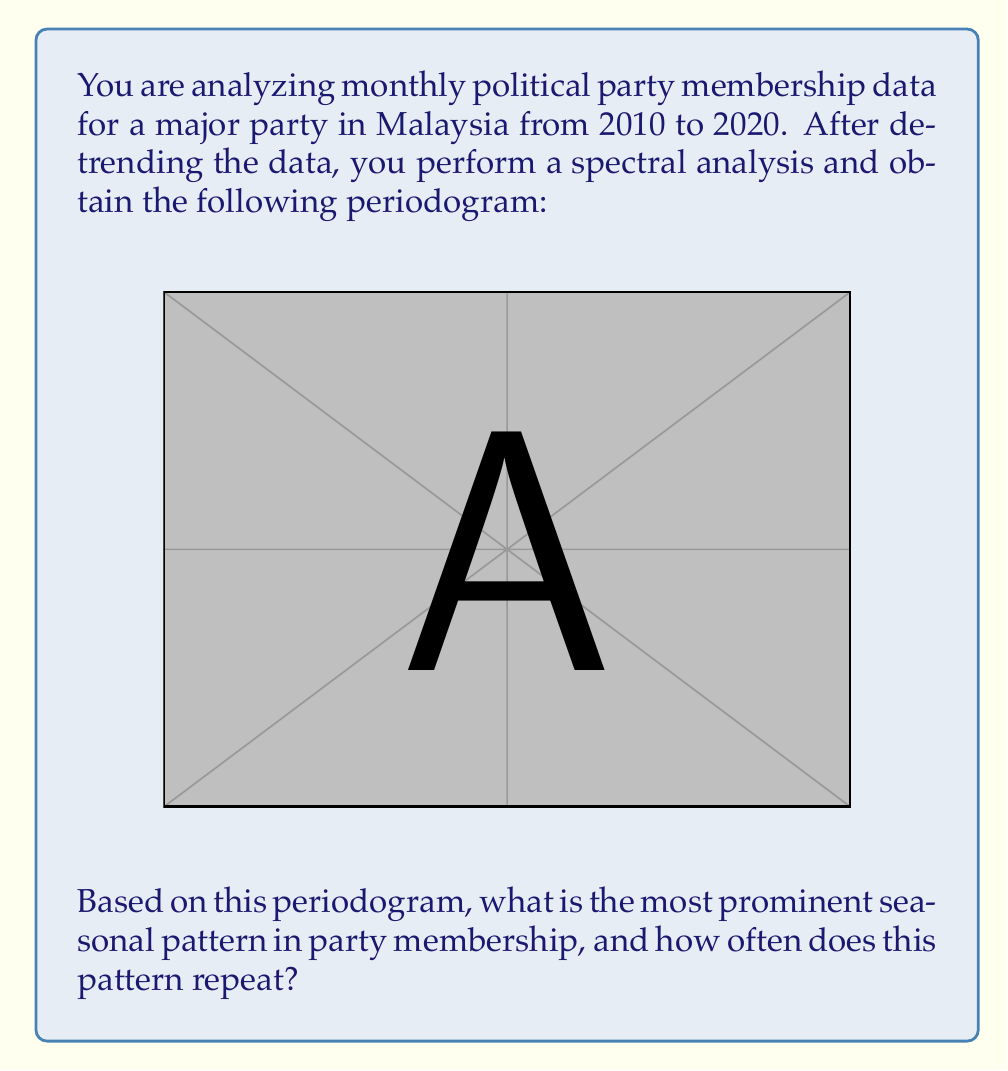What is the answer to this math problem? To identify the most prominent seasonal pattern using spectral analysis, we need to interpret the periodogram:

1) The x-axis represents frequency in cycles per month, while the y-axis represents the power (strength) of each frequency component.

2) The highest peak in the periodogram indicates the most dominant frequency in the time series.

3) In this case, the highest peak occurs at a frequency of 0.333 cycles per month.

4) To convert frequency to period (time between repetitions), we use the formula:

   $$ \text{Period} = \frac{1}{\text{Frequency}} $$

5) Substituting our frequency:

   $$ \text{Period} = \frac{1}{0.333} \approx 3 \text{ months} $$

6) This means the pattern repeats approximately every 3 months.

7) In political terms, this could indicate a quarterly cycle in party membership, possibly related to:
   - Quarterly party meetings or events
   - Seasonal political activities
   - Quarterly economic factors affecting political engagement

Therefore, the most prominent seasonal pattern in party membership repeats every 3 months or 4 times per year.
Answer: The most prominent seasonal pattern in party membership repeats every 3 months (quarterly). 